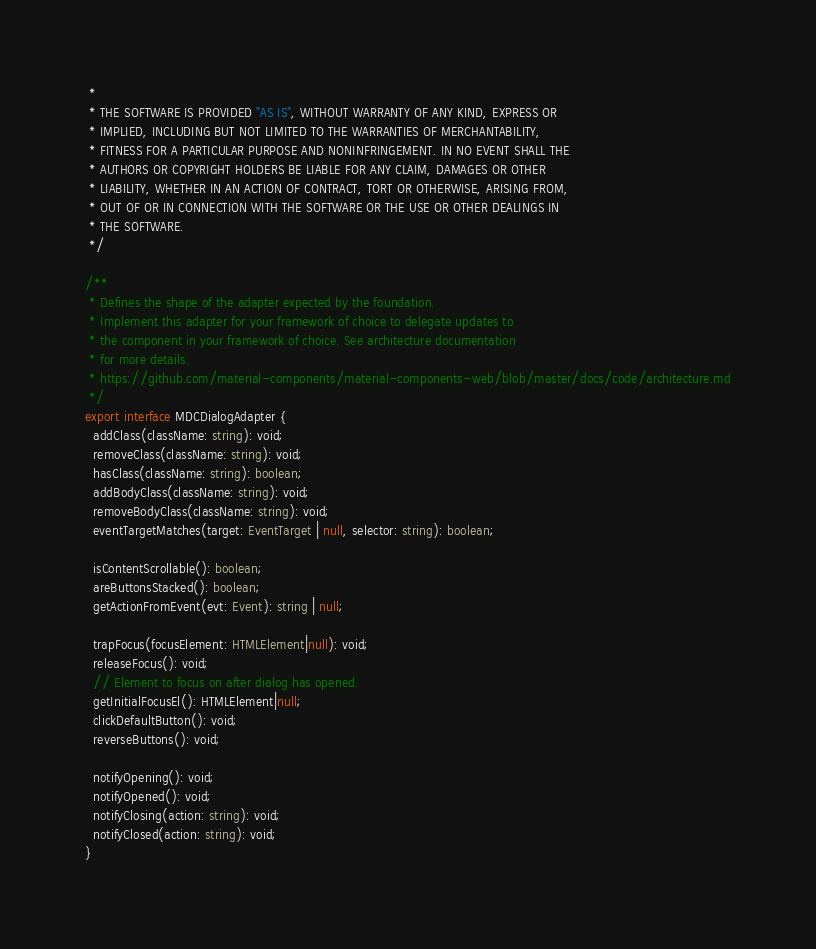<code> <loc_0><loc_0><loc_500><loc_500><_TypeScript_> *
 * THE SOFTWARE IS PROVIDED "AS IS", WITHOUT WARRANTY OF ANY KIND, EXPRESS OR
 * IMPLIED, INCLUDING BUT NOT LIMITED TO THE WARRANTIES OF MERCHANTABILITY,
 * FITNESS FOR A PARTICULAR PURPOSE AND NONINFRINGEMENT. IN NO EVENT SHALL THE
 * AUTHORS OR COPYRIGHT HOLDERS BE LIABLE FOR ANY CLAIM, DAMAGES OR OTHER
 * LIABILITY, WHETHER IN AN ACTION OF CONTRACT, TORT OR OTHERWISE, ARISING FROM,
 * OUT OF OR IN CONNECTION WITH THE SOFTWARE OR THE USE OR OTHER DEALINGS IN
 * THE SOFTWARE.
 */

/**
 * Defines the shape of the adapter expected by the foundation.
 * Implement this adapter for your framework of choice to delegate updates to
 * the component in your framework of choice. See architecture documentation
 * for more details.
 * https://github.com/material-components/material-components-web/blob/master/docs/code/architecture.md
 */
export interface MDCDialogAdapter {
  addClass(className: string): void;
  removeClass(className: string): void;
  hasClass(className: string): boolean;
  addBodyClass(className: string): void;
  removeBodyClass(className: string): void;
  eventTargetMatches(target: EventTarget | null, selector: string): boolean;

  isContentScrollable(): boolean;
  areButtonsStacked(): boolean;
  getActionFromEvent(evt: Event): string | null;

  trapFocus(focusElement: HTMLElement|null): void;
  releaseFocus(): void;
  // Element to focus on after dialog has opened.
  getInitialFocusEl(): HTMLElement|null;
  clickDefaultButton(): void;
  reverseButtons(): void;

  notifyOpening(): void;
  notifyOpened(): void;
  notifyClosing(action: string): void;
  notifyClosed(action: string): void;
}
</code> 